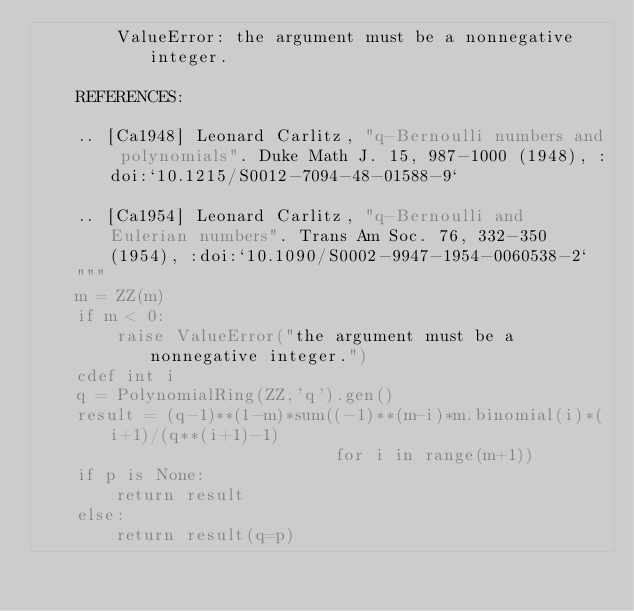<code> <loc_0><loc_0><loc_500><loc_500><_Cython_>        ValueError: the argument must be a nonnegative integer.

    REFERENCES:

    .. [Ca1948] Leonard Carlitz, "q-Bernoulli numbers and polynomials". Duke Math J. 15, 987-1000 (1948), :doi:`10.1215/S0012-7094-48-01588-9`

    .. [Ca1954] Leonard Carlitz, "q-Bernoulli and Eulerian numbers". Trans Am Soc. 76, 332-350 (1954), :doi:`10.1090/S0002-9947-1954-0060538-2`
    """
    m = ZZ(m)
    if m < 0:
        raise ValueError("the argument must be a nonnegative integer.")
    cdef int i
    q = PolynomialRing(ZZ,'q').gen()
    result = (q-1)**(1-m)*sum((-1)**(m-i)*m.binomial(i)*(i+1)/(q**(i+1)-1)
                              for i in range(m+1))
    if p is None:
        return result
    else:
        return result(q=p)
</code> 